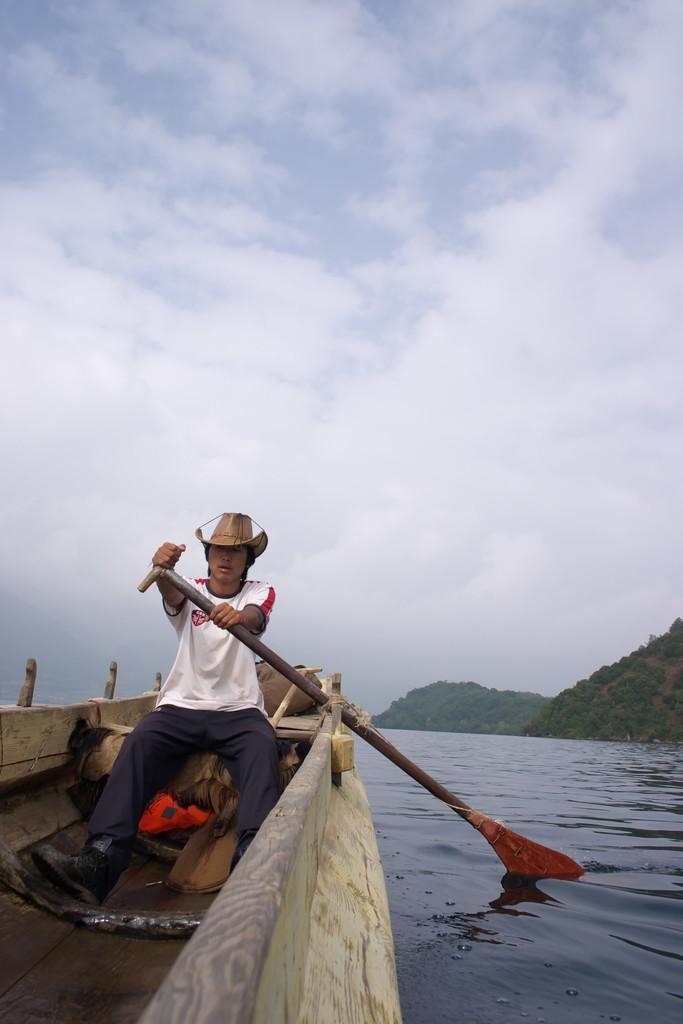Describe this image in one or two sentences. In this image there is a person sitting in the boat. He is holding a raft. He is wearing a hat. The boat is sailing on the surface of the water. Right side there are hills. Top of the image there is sky having clouds. 